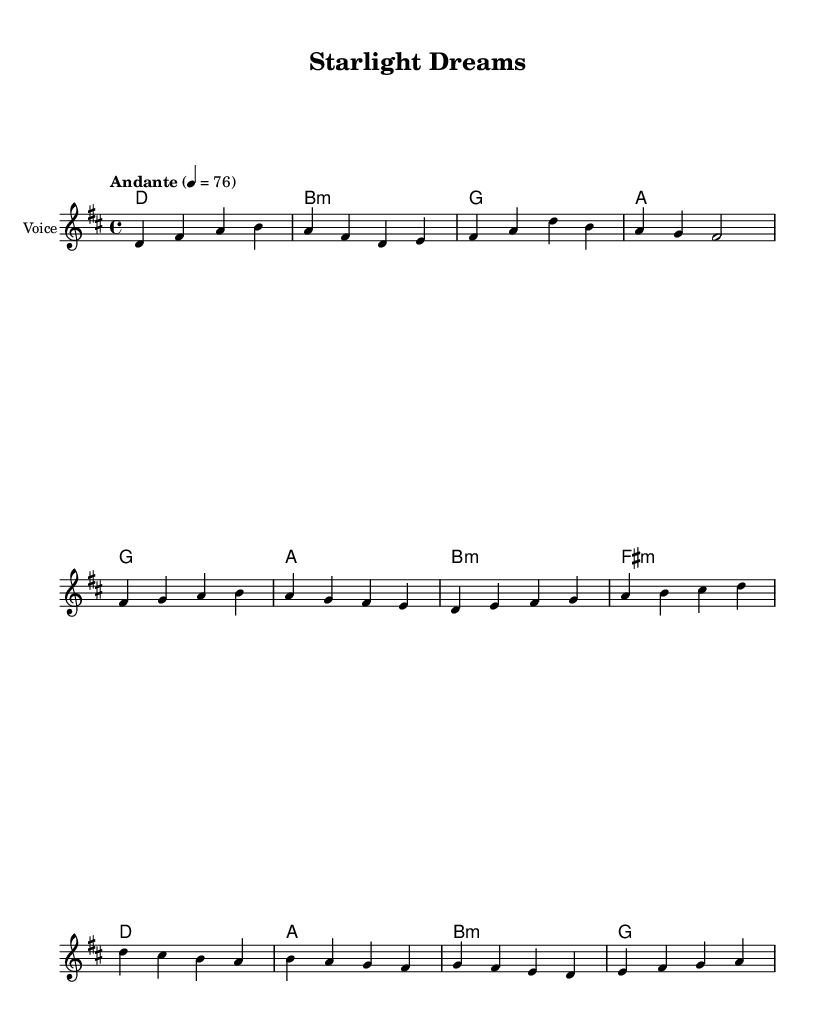What is the key signature of this music? The key signature is D major, which has two sharps (F# and C#).
Answer: D major What is the time signature of this music? The time signature is 4/4, meaning there are four beats in each measure.
Answer: 4/4 What is the tempo indication of this piece? The tempo is marked as Andante with a metronome marking of 76, indicating a moderate pace.
Answer: Andante How many measures are in the chorus section of this piece? The chorus section contains four measures, as indicated by the grouping of the notes in that section of the music.
Answer: Four Which chord follows the melody note "b" in the chorus? The chord following the melody note "b" is B minor, as it is written in the harmonies section directly below the melody.
Answer: B minor How does the pre-chorus transition to the chorus musically? The pre-chorus ends on an F# minor chord leading into a D major chord, creating a resolution and lift into the chorus, which is characteristic of K-Pop ballads.
Answer: F# minor to D major What is the primary theme reflected in this ballad? The primary theme reflects struggles and dreams of aspiring actresses, conveying emotional sentiments common in K-Pop ballads.
Answer: Struggles and dreams 